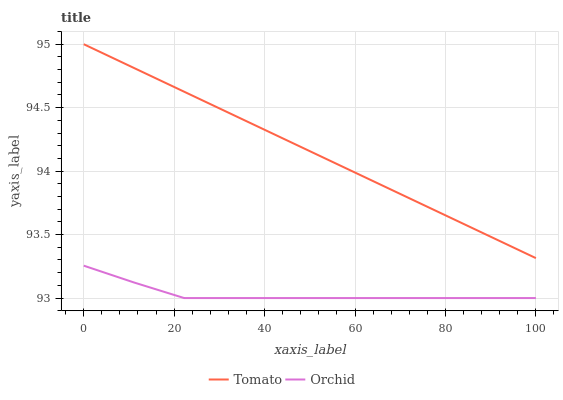Does Orchid have the minimum area under the curve?
Answer yes or no. Yes. Does Tomato have the maximum area under the curve?
Answer yes or no. Yes. Does Orchid have the maximum area under the curve?
Answer yes or no. No. Is Tomato the smoothest?
Answer yes or no. Yes. Is Orchid the roughest?
Answer yes or no. Yes. Is Orchid the smoothest?
Answer yes or no. No. Does Orchid have the lowest value?
Answer yes or no. Yes. Does Tomato have the highest value?
Answer yes or no. Yes. Does Orchid have the highest value?
Answer yes or no. No. Is Orchid less than Tomato?
Answer yes or no. Yes. Is Tomato greater than Orchid?
Answer yes or no. Yes. Does Orchid intersect Tomato?
Answer yes or no. No. 